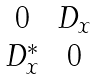<formula> <loc_0><loc_0><loc_500><loc_500>\begin{matrix} 0 & D _ { x } \\ D _ { x } ^ { \ast } & 0 \end{matrix}</formula> 